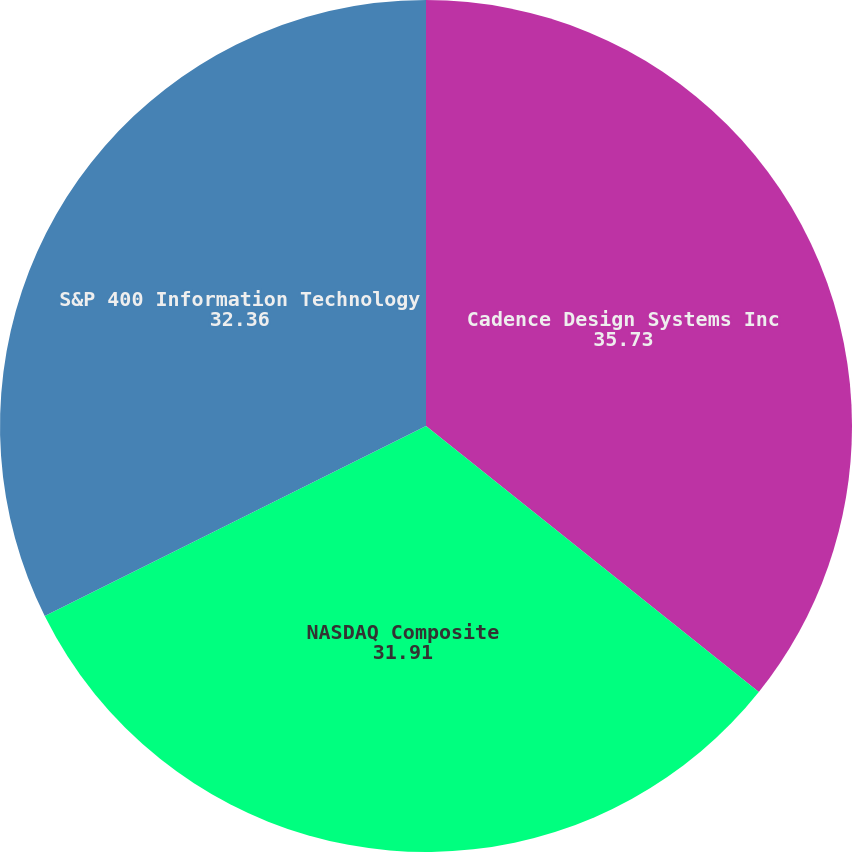Convert chart. <chart><loc_0><loc_0><loc_500><loc_500><pie_chart><fcel>Cadence Design Systems Inc<fcel>NASDAQ Composite<fcel>S&P 400 Information Technology<nl><fcel>35.73%<fcel>31.91%<fcel>32.36%<nl></chart> 